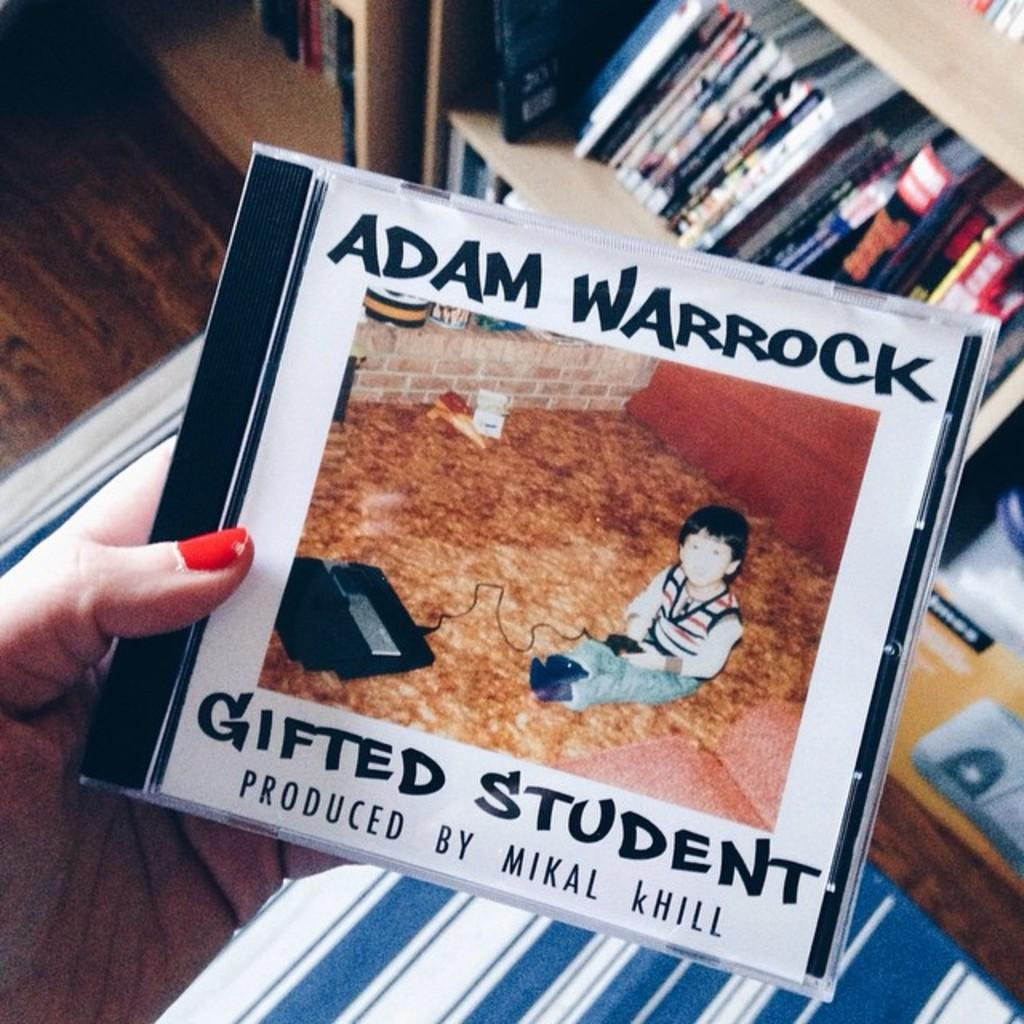<image>
Render a clear and concise summary of the photo. A music cd is titled Gifted Student and was produced by Mikal kHill. 